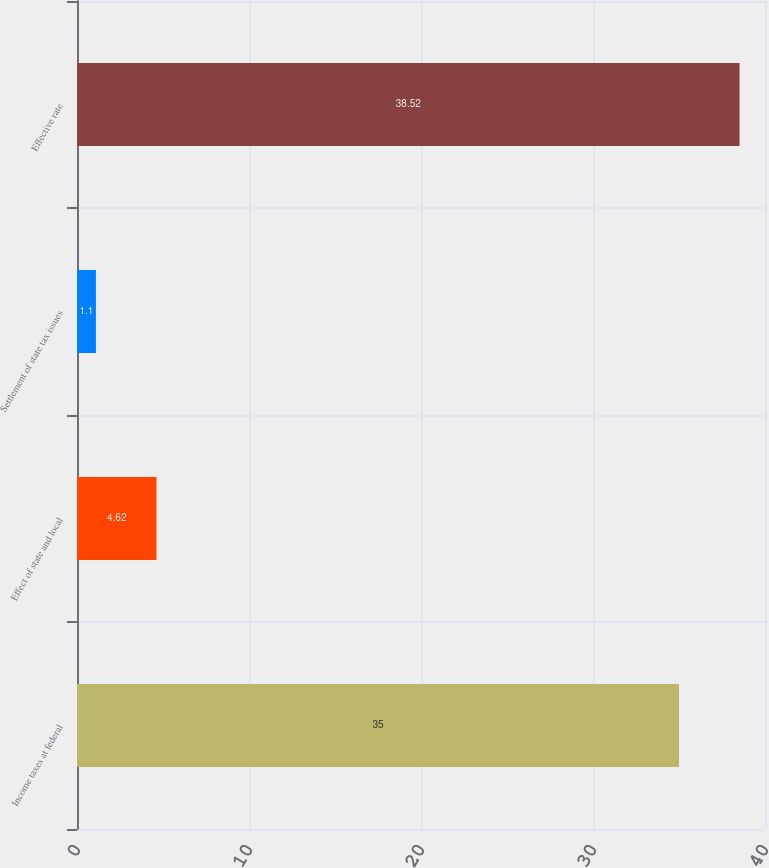Convert chart. <chart><loc_0><loc_0><loc_500><loc_500><bar_chart><fcel>Income taxes at federal<fcel>Effect of state and local<fcel>Settlement of state tax issues<fcel>Effective rate<nl><fcel>35<fcel>4.62<fcel>1.1<fcel>38.52<nl></chart> 